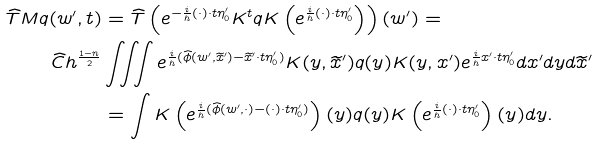Convert formula to latex. <formula><loc_0><loc_0><loc_500><loc_500>\widehat { T } M q ( w ^ { \prime } , t ) & = \widehat { T } \left ( e ^ { - \frac { i } { h } ( \cdot ) \cdot t \eta _ { 0 } ^ { \prime } } K ^ { t } q K \left ( e ^ { \frac { i } { h } ( \cdot ) \cdot t \eta _ { 0 } ^ { \prime } } \right ) \right ) ( w ^ { \prime } ) = \\ \widehat { C } h ^ { \frac { 1 - n } { 2 } } & \iiint e ^ { \frac { i } { h } ( \widehat { \phi } ( w ^ { \prime } , \widetilde { x } ^ { \prime } ) - \widetilde { x } ^ { \prime } \cdot t \eta _ { 0 } ^ { \prime } ) } K ( y , \widetilde { x } ^ { \prime } ) q ( y ) K ( y , x ^ { \prime } ) e ^ { \frac { i } { h } x ^ { \prime } \cdot t \eta _ { 0 } ^ { \prime } } d x ^ { \prime } d y d \widetilde { x } ^ { \prime } \\ & = \int K \left ( e ^ { \frac { i } { h } ( \widehat { \phi } ( w ^ { \prime } , \cdot ) - ( \cdot ) \cdot t \eta _ { 0 } ^ { \prime } ) } \right ) ( y ) q ( y ) K \left ( e ^ { \frac { i } { h } ( \cdot ) \cdot t \eta _ { 0 } ^ { \prime } } \right ) ( y ) d y .</formula> 